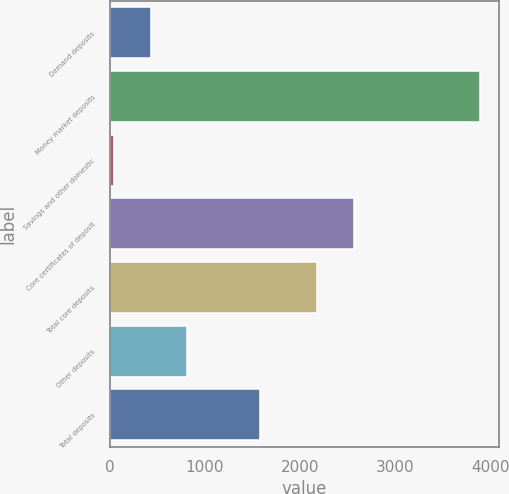Convert chart. <chart><loc_0><loc_0><loc_500><loc_500><bar_chart><fcel>Demand deposits<fcel>Money market deposits<fcel>Savings and other domestic<fcel>Core certificates of deposit<fcel>Total core deposits<fcel>Other deposits<fcel>Total deposits<nl><fcel>430.1<fcel>3887<fcel>46<fcel>2561.1<fcel>2177<fcel>814.2<fcel>1582.4<nl></chart> 